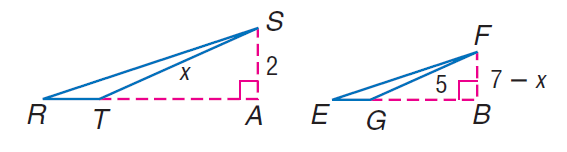Answer the mathemtical geometry problem and directly provide the correct option letter.
Question: Find F B if S A and F B are altitudes and \triangle R S T \sim \triangle E F G.
Choices: A: 1 B: 2 C: 3 D: 4 B 